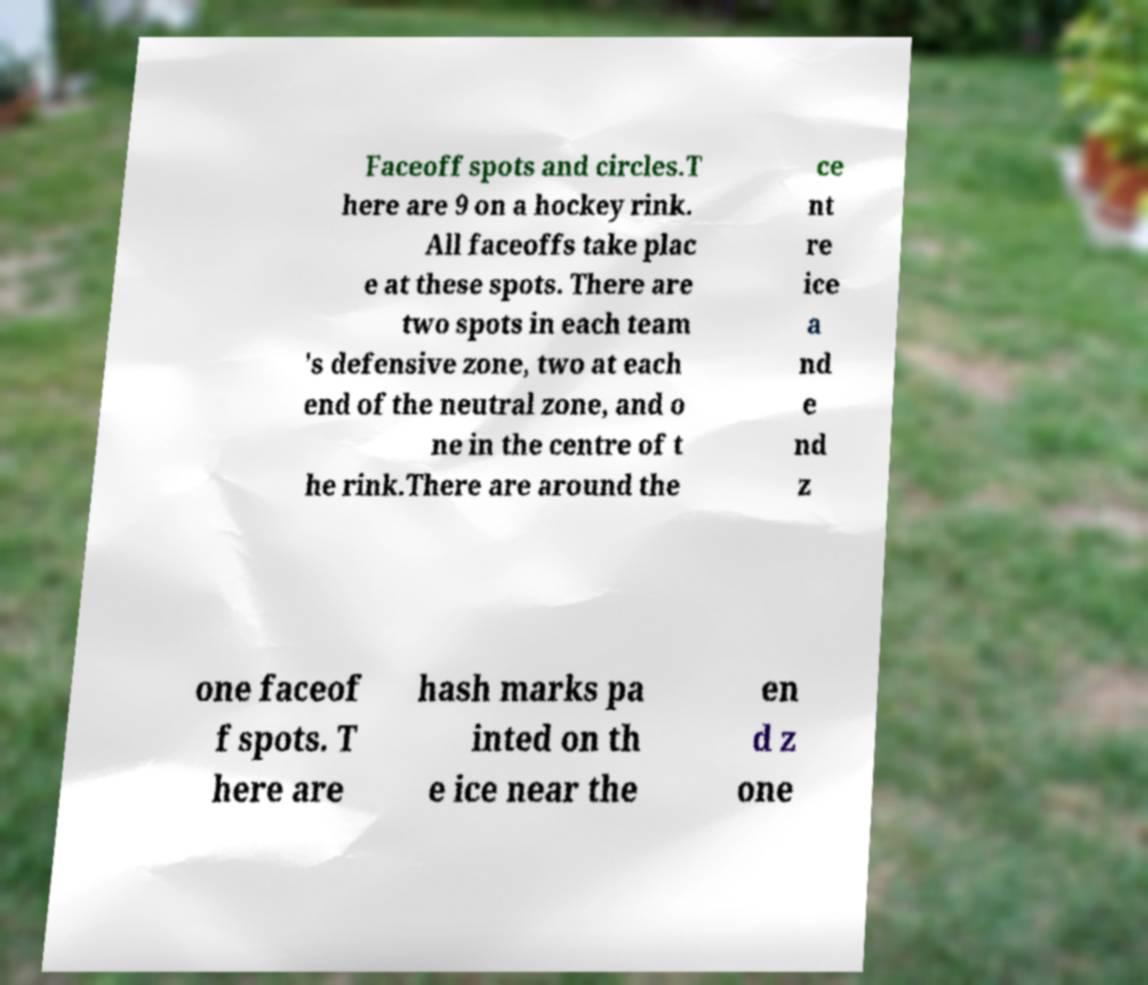Could you assist in decoding the text presented in this image and type it out clearly? Faceoff spots and circles.T here are 9 on a hockey rink. All faceoffs take plac e at these spots. There are two spots in each team 's defensive zone, two at each end of the neutral zone, and o ne in the centre of t he rink.There are around the ce nt re ice a nd e nd z one faceof f spots. T here are hash marks pa inted on th e ice near the en d z one 